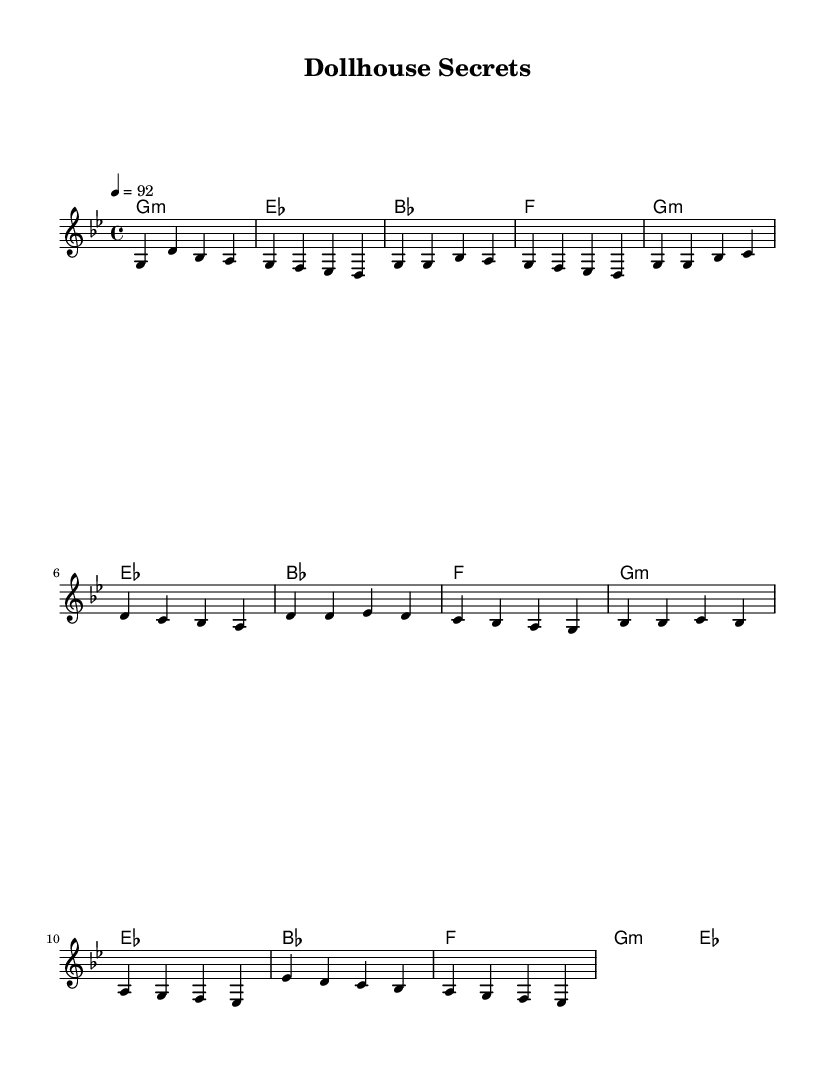What is the key signature of this music? The music is written in G minor, which has two flats in its key signature (B flat and E flat).
Answer: G minor What is the time signature of this piece? The time signature is 4/4, indicating four beats per measure and a quarter note gets one beat.
Answer: 4/4 What is the tempo marking for this music? The tempo is marked as 92 beats per minute, which affects how quickly the music should be played.
Answer: 92 How many measures are there in the melody section? The melody section consists of two verses, one chorus, and a partial bridge, totaling six measures in the main parts, but the exact number can vary if considering the full score. A total of 8 full phrases that spans across those sections is evident.
Answer: 8 Which chord follows the G minor chord in the harmony section? The chord following G minor in the harmony is E flat major, appearing right after the first G minor chord in the cycle.
Answer: E flat What kind of musical elements are present in this hip hop tune? The piece integrates a steady rhythmic structure with a repetitive melody, commonly found in hip hop, showcasing a narrative structure that hints at storytelling with dolls and toys.
Answer: Rhythmic structure What is the main theme expressed in the title "Dollhouse Secrets"? The title suggests a theme focusing on uncovering hidden stories and lives of dolls and toys when they are alone, aligning with the imaginative play typical of dollhouses.
Answer: Hidden lives 